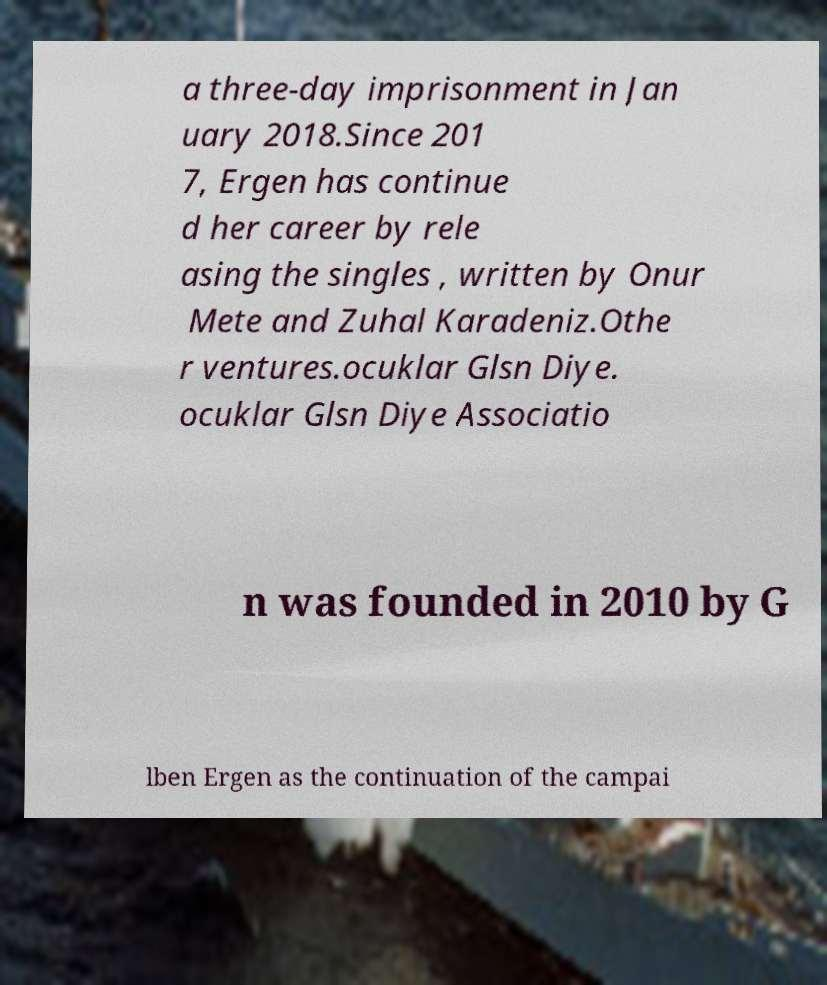Could you assist in decoding the text presented in this image and type it out clearly? a three-day imprisonment in Jan uary 2018.Since 201 7, Ergen has continue d her career by rele asing the singles , written by Onur Mete and Zuhal Karadeniz.Othe r ventures.ocuklar Glsn Diye. ocuklar Glsn Diye Associatio n was founded in 2010 by G lben Ergen as the continuation of the campai 